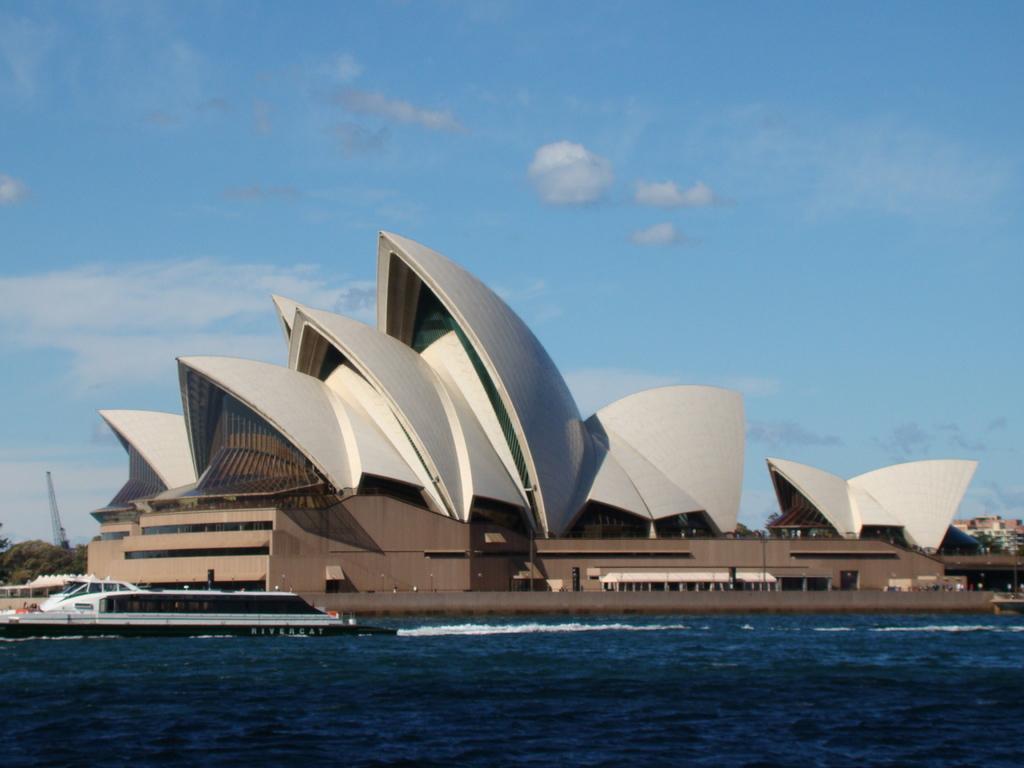Can you describe this image briefly? In this picture we can see a ship on the water, in the background we can see few buildings, trees, a crane and clouds. 